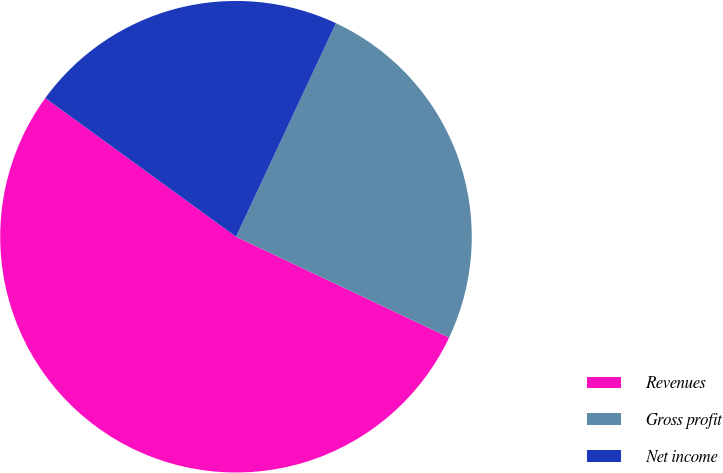Convert chart to OTSL. <chart><loc_0><loc_0><loc_500><loc_500><pie_chart><fcel>Revenues<fcel>Gross profit<fcel>Net income<nl><fcel>52.97%<fcel>25.06%<fcel>21.96%<nl></chart> 